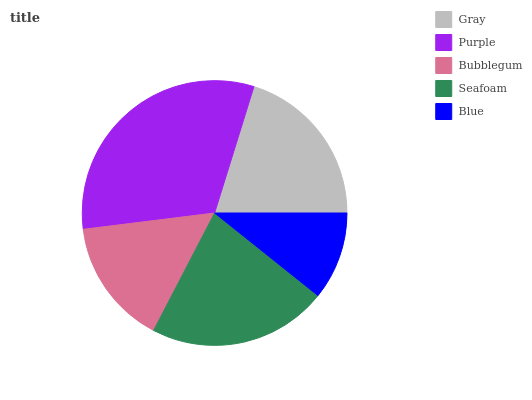Is Blue the minimum?
Answer yes or no. Yes. Is Purple the maximum?
Answer yes or no. Yes. Is Bubblegum the minimum?
Answer yes or no. No. Is Bubblegum the maximum?
Answer yes or no. No. Is Purple greater than Bubblegum?
Answer yes or no. Yes. Is Bubblegum less than Purple?
Answer yes or no. Yes. Is Bubblegum greater than Purple?
Answer yes or no. No. Is Purple less than Bubblegum?
Answer yes or no. No. Is Gray the high median?
Answer yes or no. Yes. Is Gray the low median?
Answer yes or no. Yes. Is Seafoam the high median?
Answer yes or no. No. Is Blue the low median?
Answer yes or no. No. 